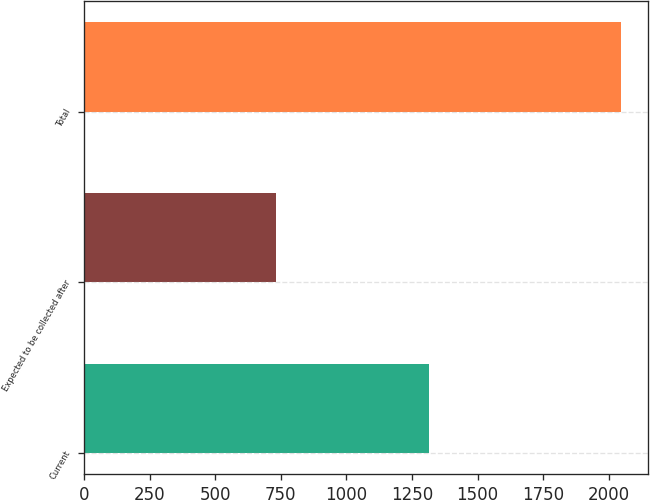Convert chart. <chart><loc_0><loc_0><loc_500><loc_500><bar_chart><fcel>Current<fcel>Expected to be collected after<fcel>Total<nl><fcel>1316<fcel>730<fcel>2046<nl></chart> 